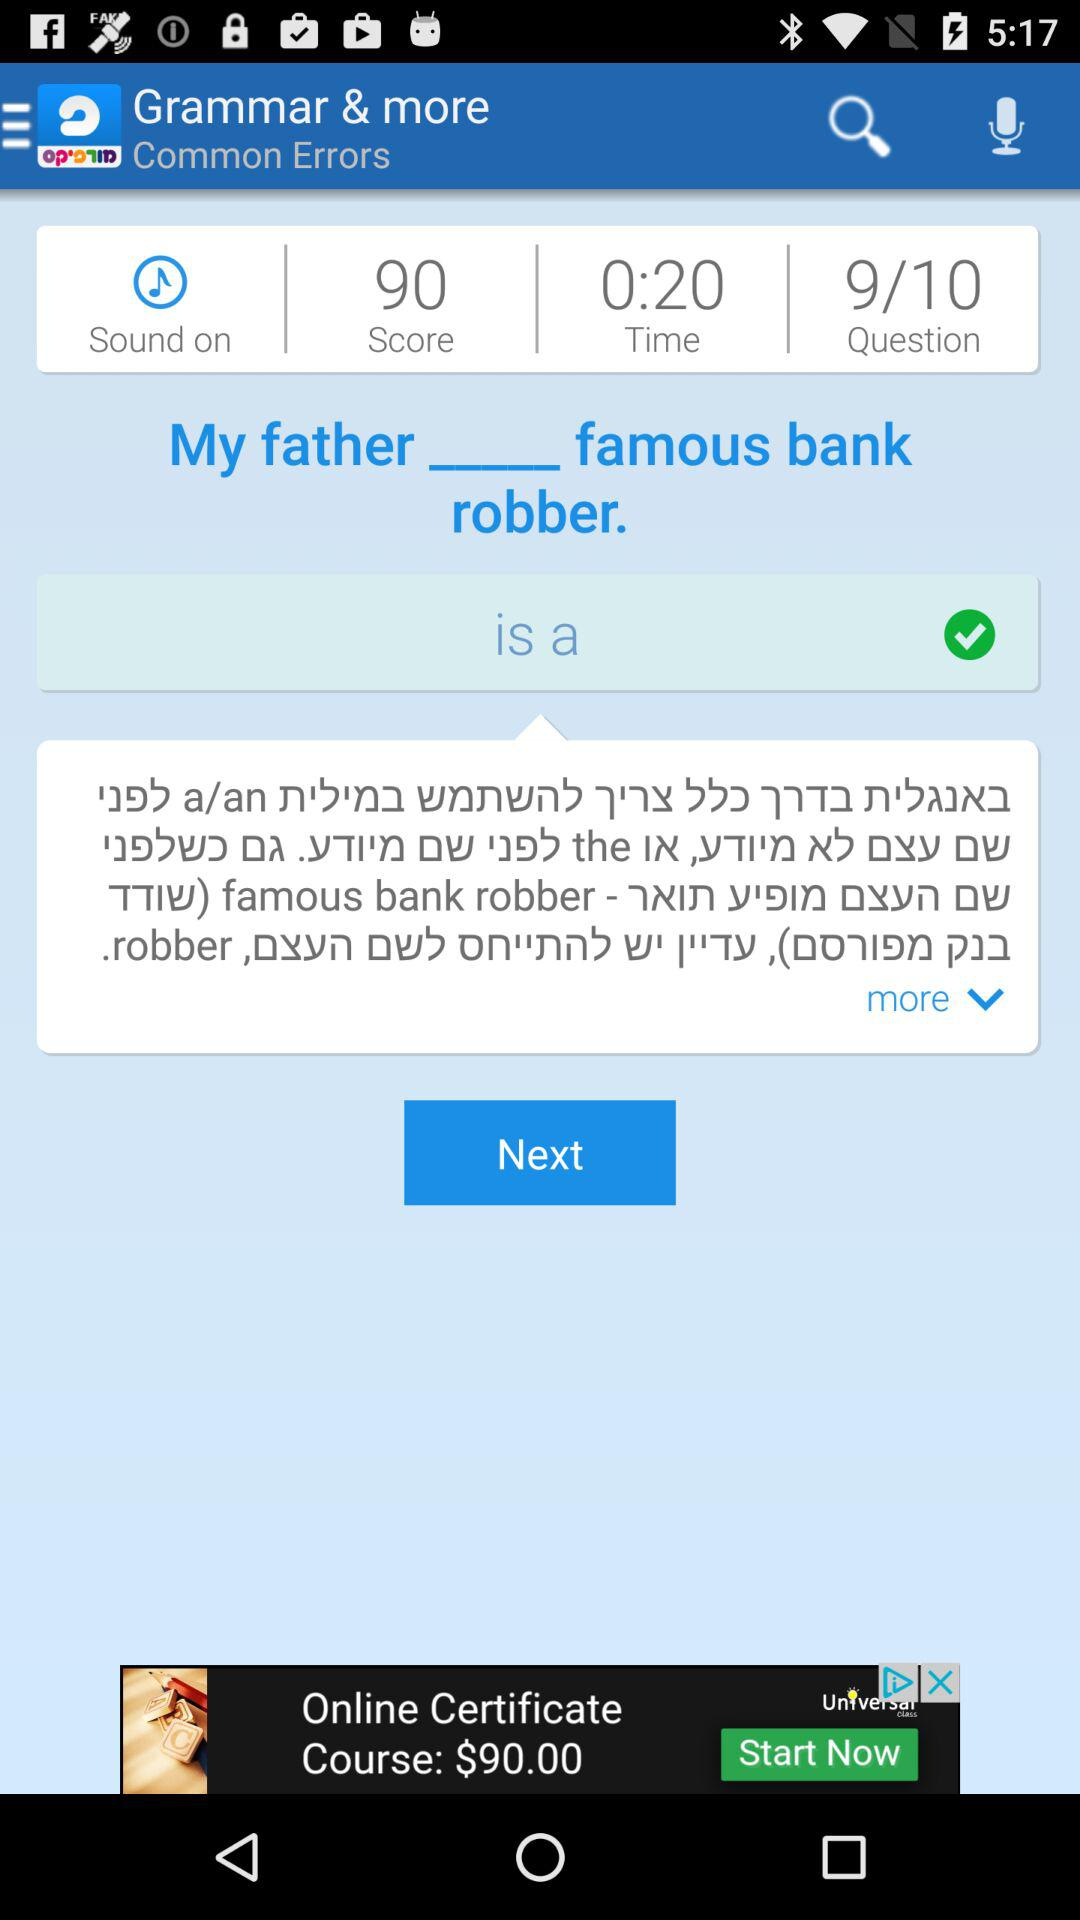What is the time? The time is 20 seconds. 